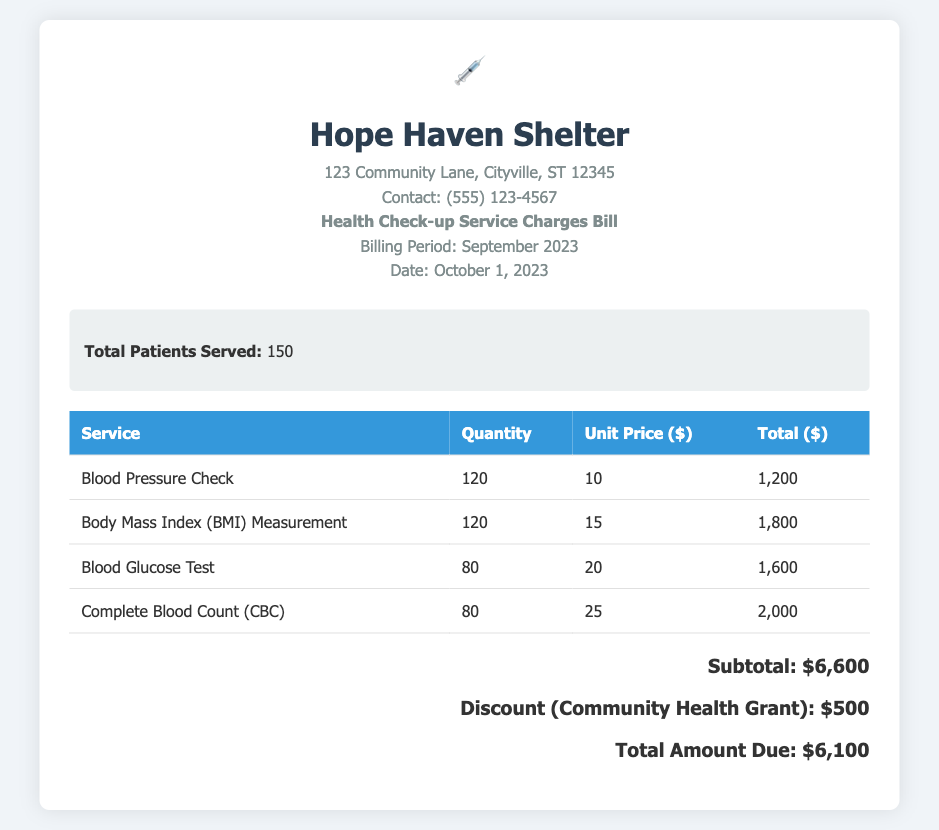What is the name of the shelter? The document states the name of the shelter at the top, which is "Hope Haven Shelter."
Answer: Hope Haven Shelter What is the billing period? The billing period is mentioned clearly in the document as September 2023.
Answer: September 2023 How many patients were served? The total number of patients served is summarized in the document, which is 150.
Answer: 150 What was the unit price for a Complete Blood Count? The bill lists the unit price for a Complete Blood Count, which is $25.
Answer: 25 What is the total amount due after the discount? The total amount due is calculated in the document, considering discounts, which is $6,100.
Answer: 6,100 What is the subtotal before any discounts? The subtotal before discounts is indicated in the document as $6,600.
Answer: 6,600 How much was the discount provided? The document specifies the discount given as part of the community health grant, which is $500.
Answer: 500 How many Blood Glucose Tests were performed? The quantity of Blood Glucose Tests performed is recorded in the bill as 80.
Answer: 80 What service had the highest total cost? By comparing total costs, the highest is for a Complete Blood Count, with a total of $2,000.
Answer: Complete Blood Count 